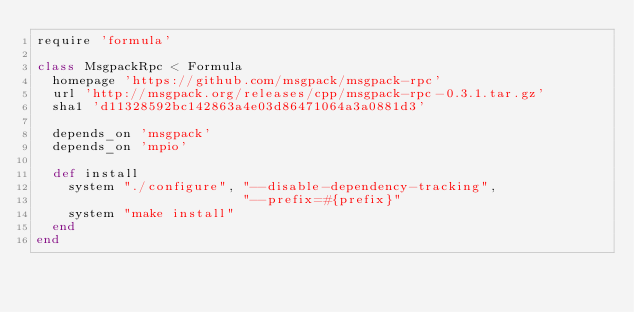<code> <loc_0><loc_0><loc_500><loc_500><_Ruby_>require 'formula'

class MsgpackRpc < Formula
  homepage 'https://github.com/msgpack/msgpack-rpc'
  url 'http://msgpack.org/releases/cpp/msgpack-rpc-0.3.1.tar.gz'
  sha1 'd11328592bc142863a4e03d86471064a3a0881d3'

  depends_on 'msgpack'
  depends_on 'mpio'

  def install
    system "./configure", "--disable-dependency-tracking",
                          "--prefix=#{prefix}"
    system "make install"
  end
end
</code> 